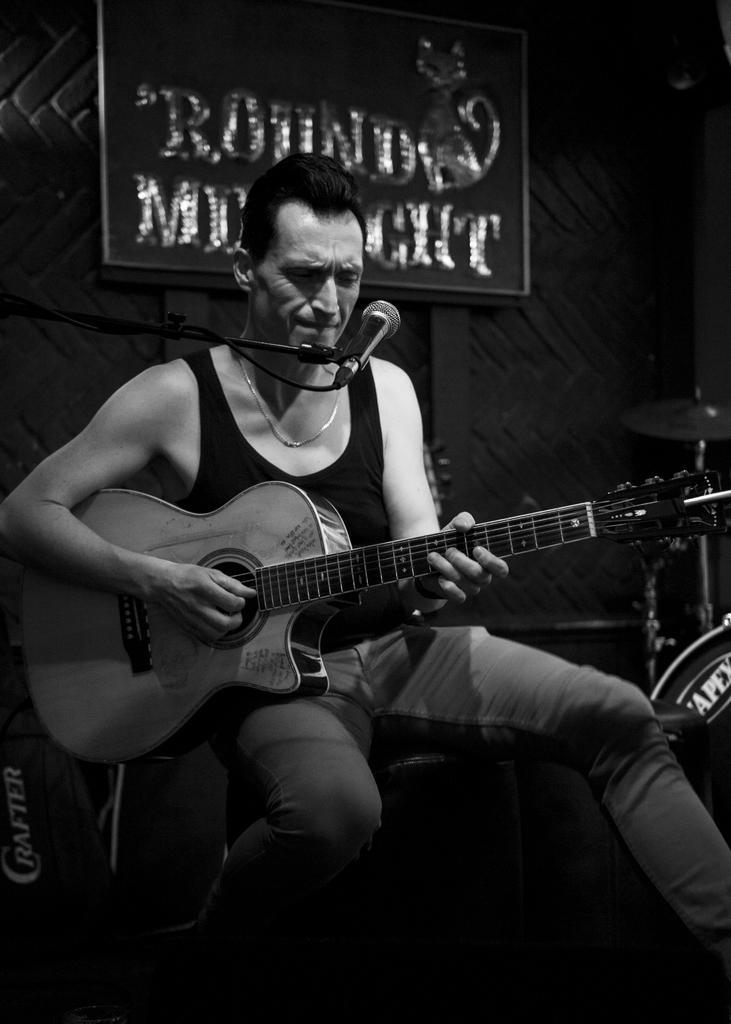Can you describe this image briefly? This person sitting and holding guitar. There is a microphone with stand. On the background we can see board,wall. 